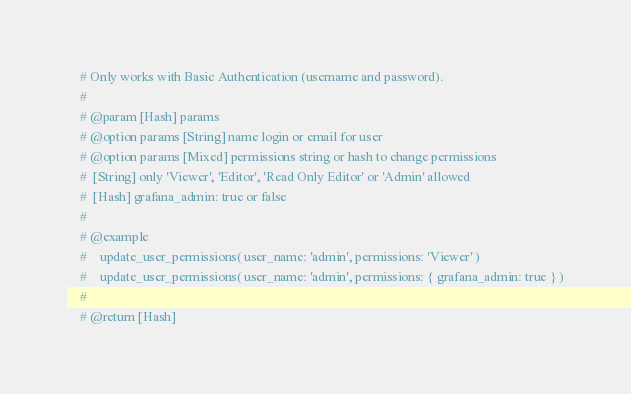Convert code to text. <code><loc_0><loc_0><loc_500><loc_500><_Ruby_>    # Only works with Basic Authentication (username and password).
    #
    # @param [Hash] params
    # @option params [String] name login or email for user
    # @option params [Mixed] permissions string or hash to change permissions
    #  [String] only 'Viewer', 'Editor', 'Read Only Editor' or 'Admin' allowed
    #  [Hash] grafana_admin: true or false
    #
    # @example
    #    update_user_permissions( user_name: 'admin', permissions: 'Viewer' )
    #    update_user_permissions( user_name: 'admin', permissions: { grafana_admin: true } )
    #
    # @return [Hash]</code> 